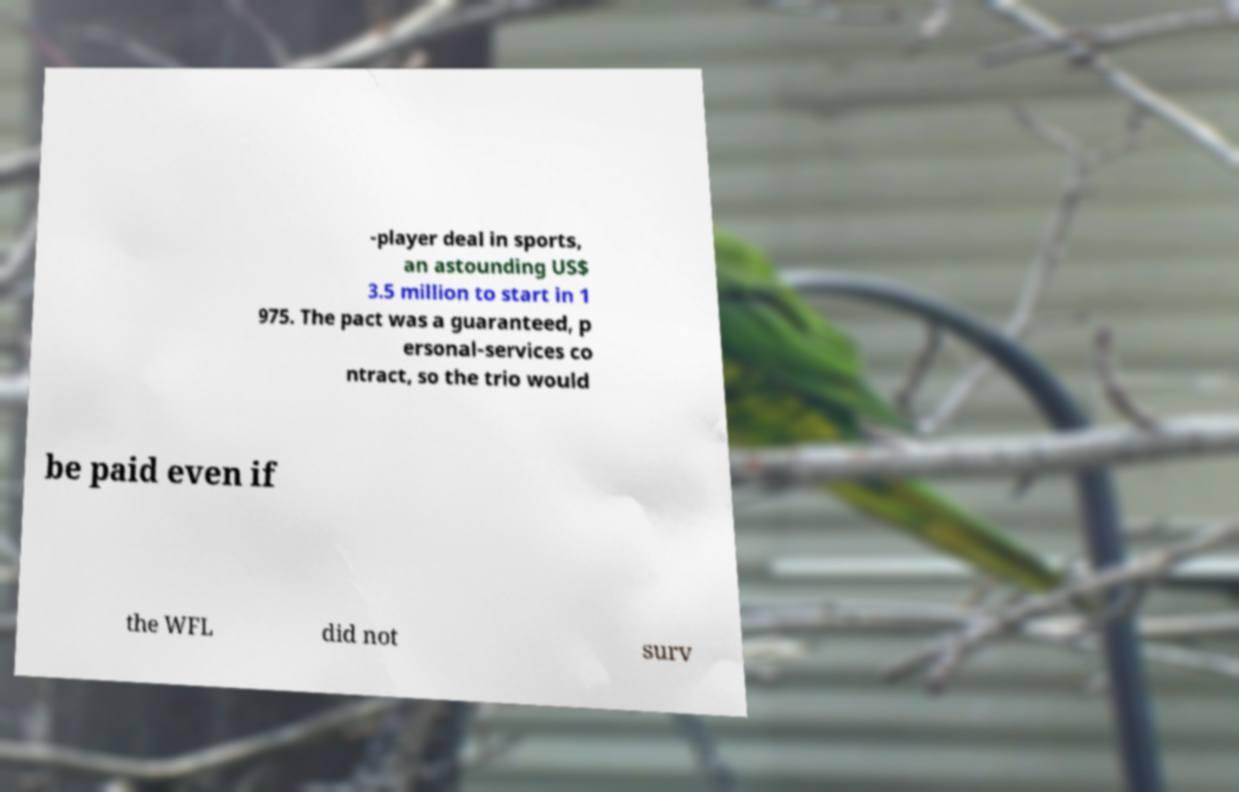Please read and relay the text visible in this image. What does it say? -player deal in sports, an astounding US$ 3.5 million to start in 1 975. The pact was a guaranteed, p ersonal-services co ntract, so the trio would be paid even if the WFL did not surv 